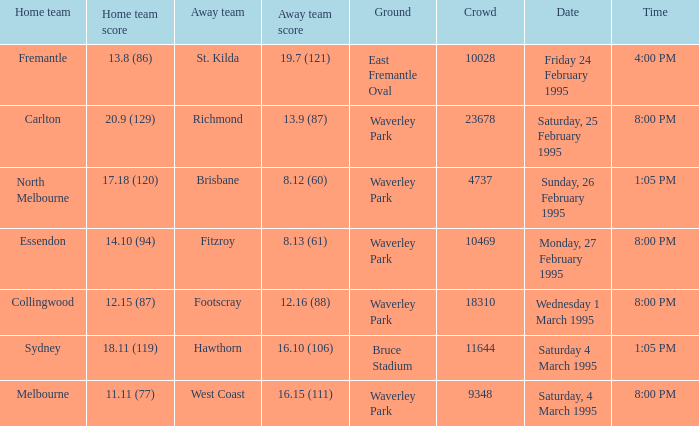Would you be able to parse every entry in this table? {'header': ['Home team', 'Home team score', 'Away team', 'Away team score', 'Ground', 'Crowd', 'Date', 'Time'], 'rows': [['Fremantle', '13.8 (86)', 'St. Kilda', '19.7 (121)', 'East Fremantle Oval', '10028', 'Friday 24 February 1995', '4:00 PM'], ['Carlton', '20.9 (129)', 'Richmond', '13.9 (87)', 'Waverley Park', '23678', 'Saturday, 25 February 1995', '8:00 PM'], ['North Melbourne', '17.18 (120)', 'Brisbane', '8.12 (60)', 'Waverley Park', '4737', 'Sunday, 26 February 1995', '1:05 PM'], ['Essendon', '14.10 (94)', 'Fitzroy', '8.13 (61)', 'Waverley Park', '10469', 'Monday, 27 February 1995', '8:00 PM'], ['Collingwood', '12.15 (87)', 'Footscray', '12.16 (88)', 'Waverley Park', '18310', 'Wednesday 1 March 1995', '8:00 PM'], ['Sydney', '18.11 (119)', 'Hawthorn', '16.10 (106)', 'Bruce Stadium', '11644', 'Saturday 4 March 1995', '1:05 PM'], ['Melbourne', '11.11 (77)', 'West Coast', '16.15 (111)', 'Waverley Park', '9348', 'Saturday, 4 March 1995', '8:00 PM']]} Can you provide the exact time for march 4, 1995, which was a saturday? 1:05 PM. 